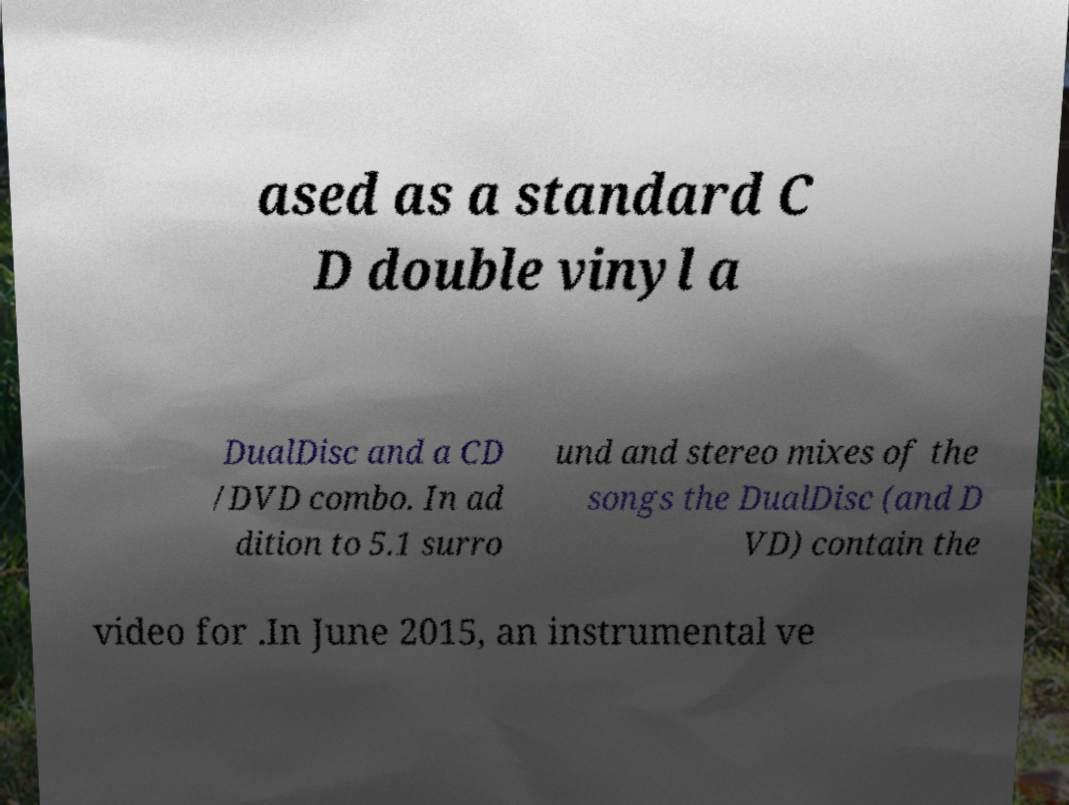There's text embedded in this image that I need extracted. Can you transcribe it verbatim? ased as a standard C D double vinyl a DualDisc and a CD /DVD combo. In ad dition to 5.1 surro und and stereo mixes of the songs the DualDisc (and D VD) contain the video for .In June 2015, an instrumental ve 